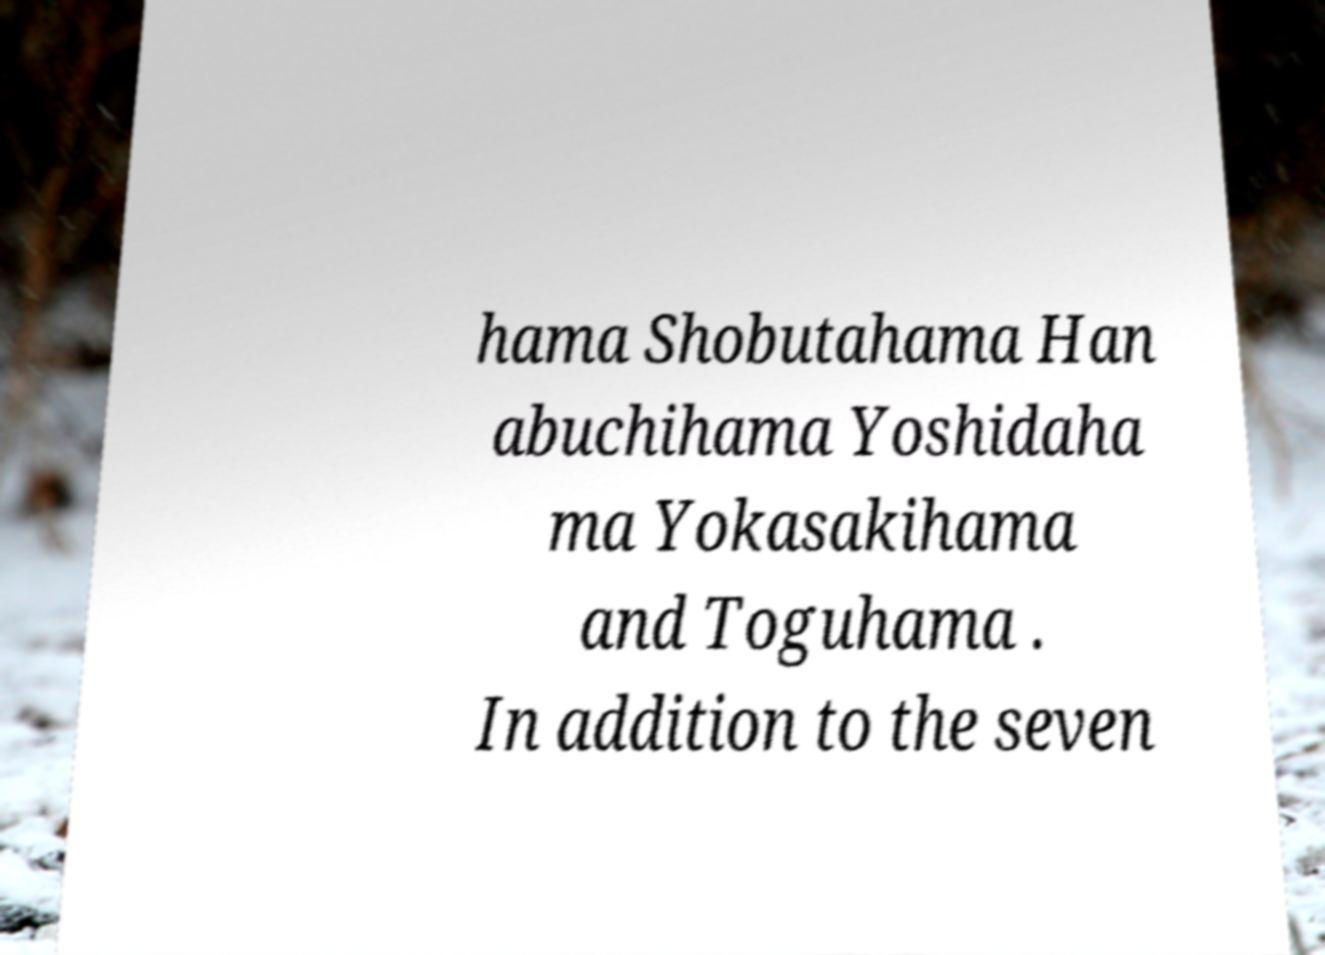Please read and relay the text visible in this image. What does it say? hama Shobutahama Han abuchihama Yoshidaha ma Yokasakihama and Toguhama . In addition to the seven 